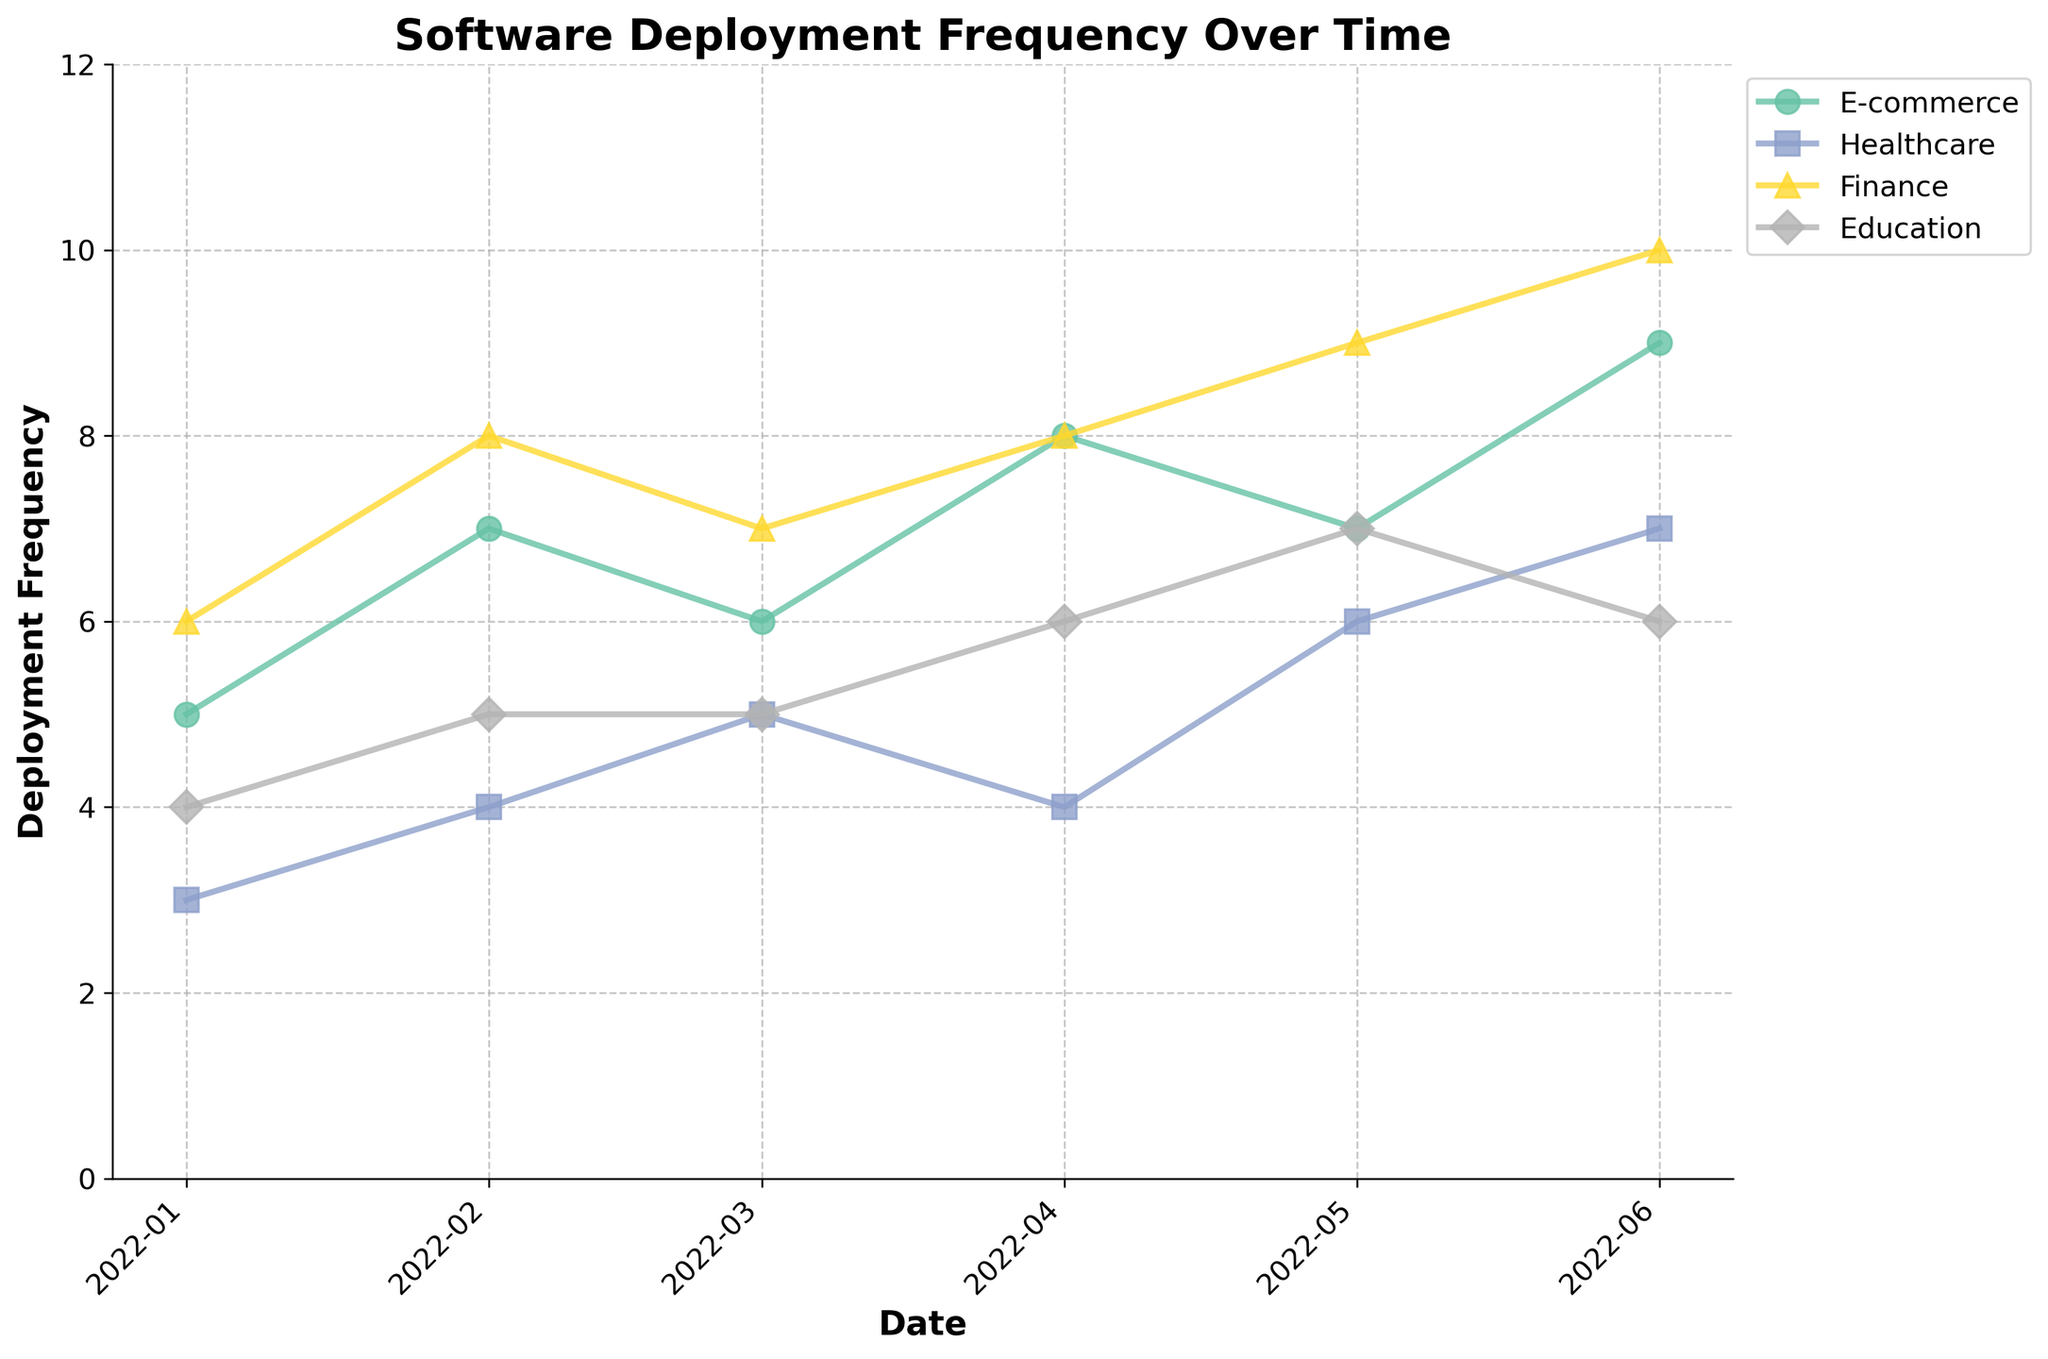What's the title of the plot? The title is located at the top center of the plot in larger and bold font. It describes the overview of the plot.
Answer: Software Deployment Frequency Over Time What is the deployment frequency for Healthcare in April 2022? To find this, locate the 'Healthcare' line (typically marked by a specific color and marker) and check the point corresponding to April 2022 on the x-axis. The y-axis value for this point gives the deployment frequency.
Answer: 4 Which project type had the highest deployment frequency in June 2022? Move to the June 2022 date on the x-axis. Compare the y-axis values of all project types and identify the one with the highest point.
Answer: Finance Which month saw the highest deployment frequency for the E-commerce project type? Follow the E-commerce line across the months. The peak is the highest point on the y-axis, indicating the month with the highest frequency.
Answer: June 2022 What is the trend of deployment frequency for the Education project type from January to June 2022? Observe the Education line's overall direction from January to June 2022. Notice whether it is generally increasing, decreasing, or fluctuating.
Answer: Increasing How many different project types are represented in the plot? Identify the distinct labels in the legend, representing each project type. Count the unique project types.
Answer: 4 In which month did Healthcare surpass E-commerce in deployment frequency for the first time? Compare the deployment frequency lines of 'Healthcare' and 'E-commerce' from January to June 2022. Identify the earliest month when Healthcare's line is above E-commerce's.
Answer: May 2022 Comparing Finance and Education deployment frequencies, which has a higher value in March 2022? Locate March 2022 on the x-axis and compare the y-axis values of 'Finance' and 'Education' project types at this date. The higher value indicates the answer.
Answer: Finance What's the average deployment frequency for Healthcare across the given time period? Extract the deployment frequencies for Healthcare across all months: 3, 4, 5, 4, 6, 7. Sum these values and divide by the number of months (6). Calculation: (3 + 4 + 5 + 4 + 6 + 7) / 6 = 29 / 6 ≈ 4.83
Answer: 4.83 